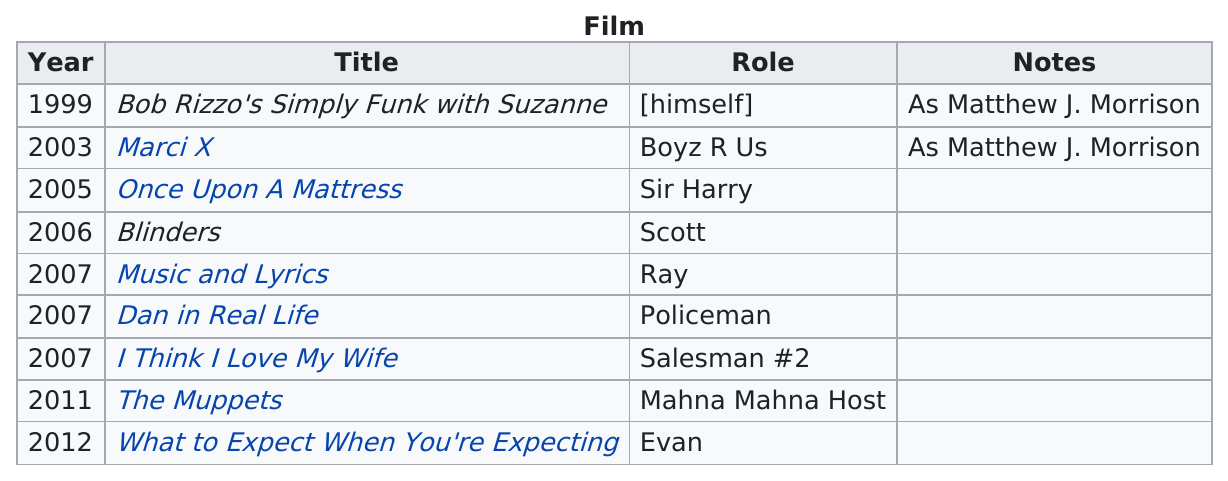Indicate a few pertinent items in this graphic. In the year 1999, Matthew J. Morrison's first film was released. In the movie "Dan in Real Life," Matthew J. Morrison played the character of a policeman, and the movie was released in the year 2007. In the year 2007, James Morrison collaborated with various film projects, including "Music and Lyrics," "Dan in Real Life," and "I Think I Love My Wife. In the year 2007, the greatest number of Matthew J. Morrison films were released. The number of movies that Morrison has acted in after 2010 is two. 